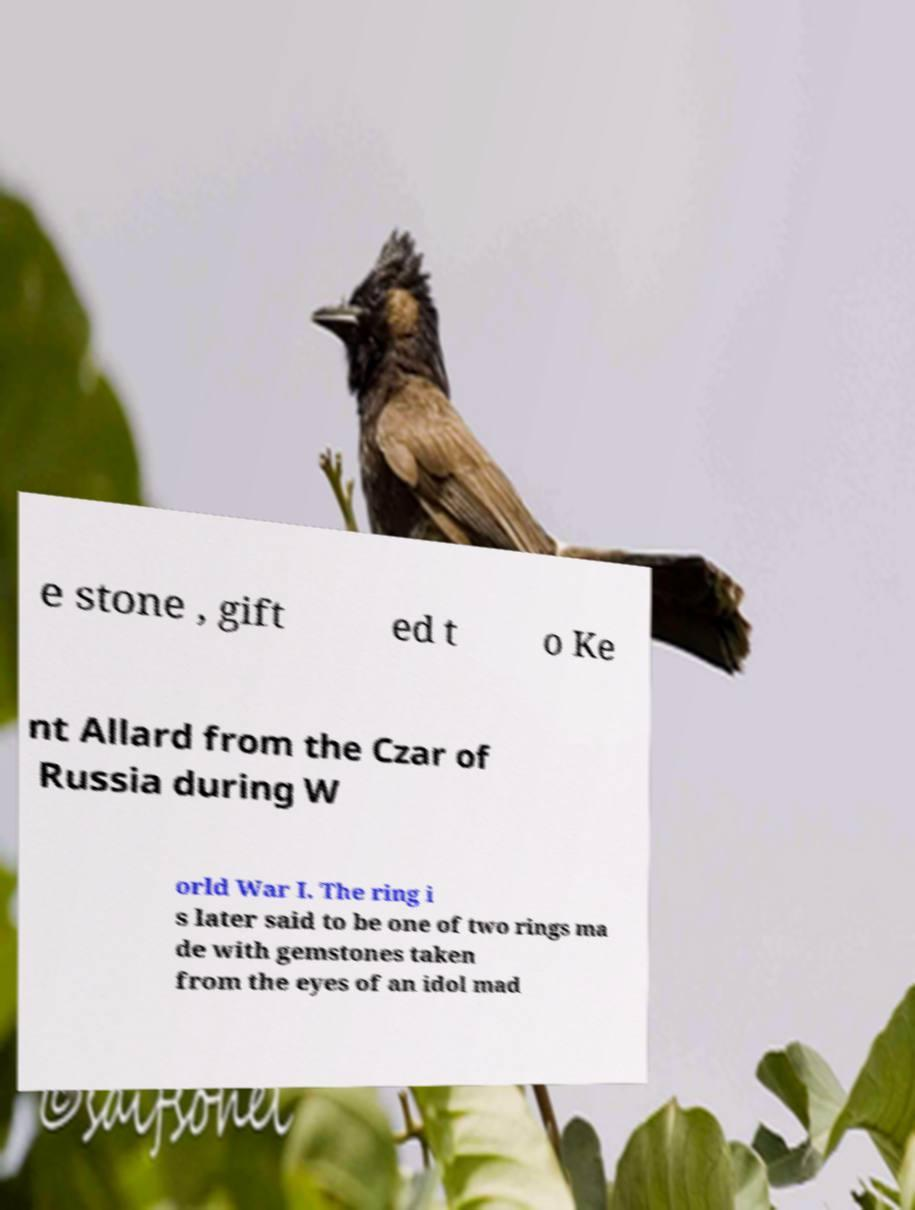Can you accurately transcribe the text from the provided image for me? e stone , gift ed t o Ke nt Allard from the Czar of Russia during W orld War I. The ring i s later said to be one of two rings ma de with gemstones taken from the eyes of an idol mad 